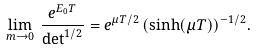<formula> <loc_0><loc_0><loc_500><loc_500>\lim _ { m \to 0 } \, \frac { e ^ { E _ { 0 } T } } { \det ^ { 1 / 2 } } = e ^ { \mu T / 2 } \, ( \sinh ( \mu T ) ) ^ { - 1 / 2 } .</formula> 